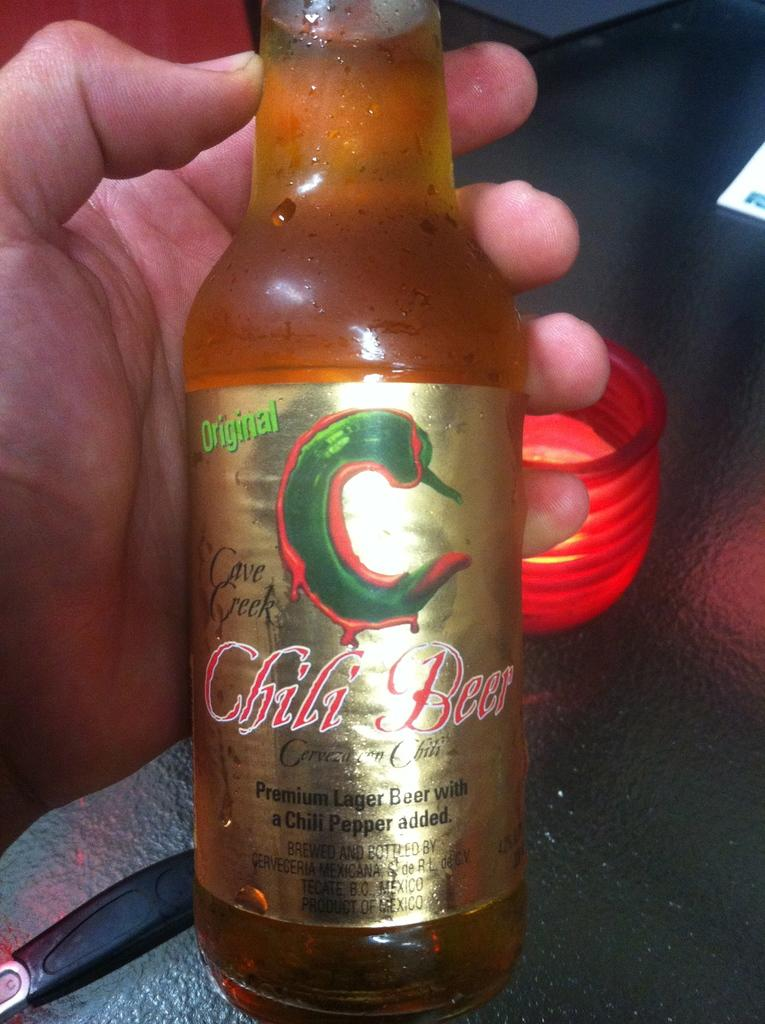<image>
Write a terse but informative summary of the picture. A person holds a chilled Chili Beer with a chili pepper in the shape of a C on the front. 